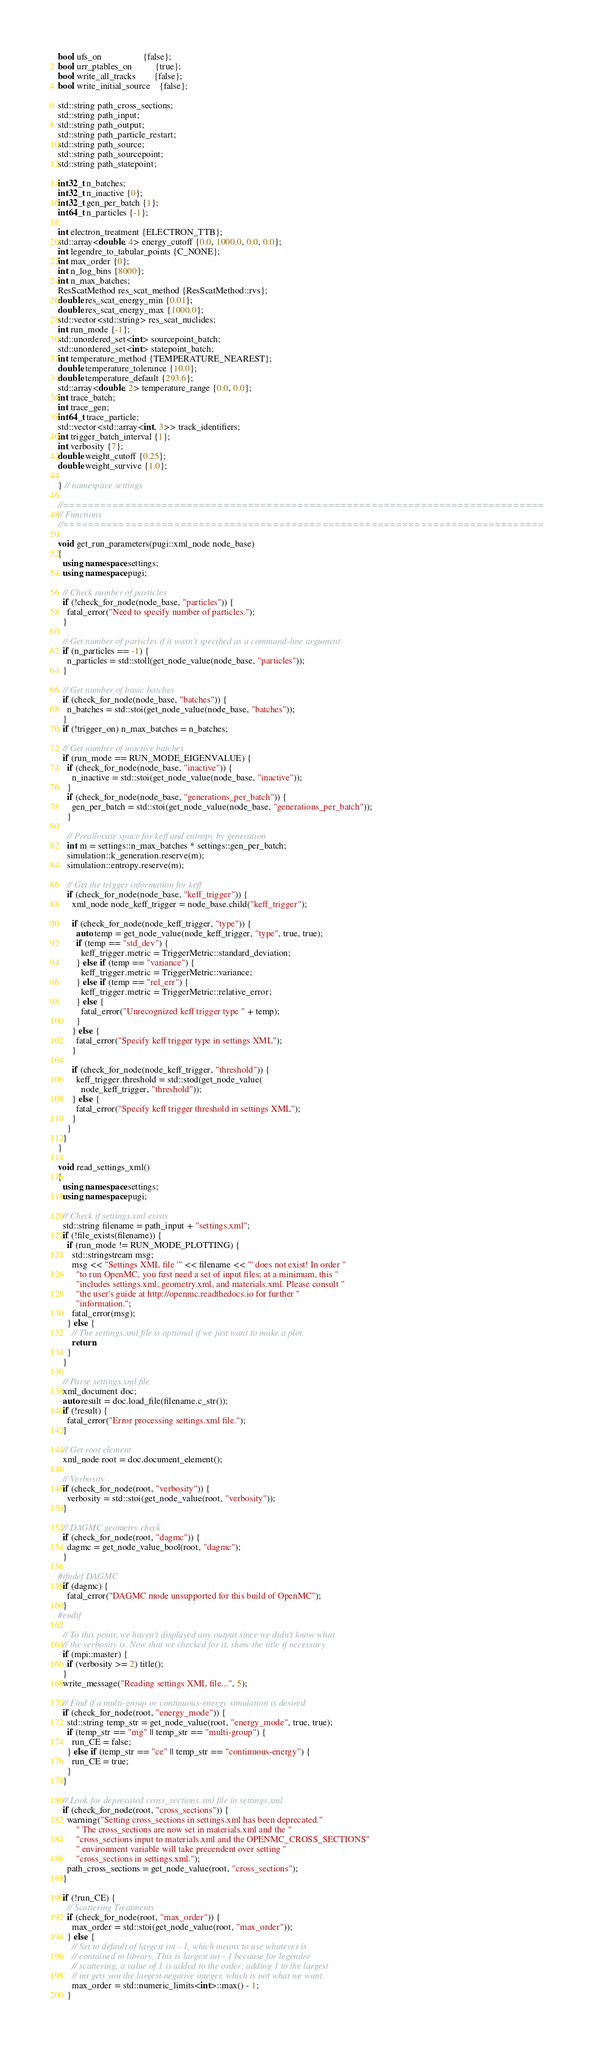<code> <loc_0><loc_0><loc_500><loc_500><_C++_>bool ufs_on                  {false};
bool urr_ptables_on          {true};
bool write_all_tracks        {false};
bool write_initial_source    {false};

std::string path_cross_sections;
std::string path_input;
std::string path_output;
std::string path_particle_restart;
std::string path_source;
std::string path_sourcepoint;
std::string path_statepoint;

int32_t n_batches;
int32_t n_inactive {0};
int32_t gen_per_batch {1};
int64_t n_particles {-1};

int electron_treatment {ELECTRON_TTB};
std::array<double, 4> energy_cutoff {0.0, 1000.0, 0.0, 0.0};
int legendre_to_tabular_points {C_NONE};
int max_order {0};
int n_log_bins {8000};
int n_max_batches;
ResScatMethod res_scat_method {ResScatMethod::rvs};
double res_scat_energy_min {0.01};
double res_scat_energy_max {1000.0};
std::vector<std::string> res_scat_nuclides;
int run_mode {-1};
std::unordered_set<int> sourcepoint_batch;
std::unordered_set<int> statepoint_batch;
int temperature_method {TEMPERATURE_NEAREST};
double temperature_tolerance {10.0};
double temperature_default {293.6};
std::array<double, 2> temperature_range {0.0, 0.0};
int trace_batch;
int trace_gen;
int64_t trace_particle;
std::vector<std::array<int, 3>> track_identifiers;
int trigger_batch_interval {1};
int verbosity {7};
double weight_cutoff {0.25};
double weight_survive {1.0};

} // namespace settings

//==============================================================================
// Functions
//==============================================================================

void get_run_parameters(pugi::xml_node node_base)
{
  using namespace settings;
  using namespace pugi;

  // Check number of particles
  if (!check_for_node(node_base, "particles")) {
    fatal_error("Need to specify number of particles.");
  }

  // Get number of particles if it wasn't specified as a command-line argument
  if (n_particles == -1) {
    n_particles = std::stoll(get_node_value(node_base, "particles"));
  }

  // Get number of basic batches
  if (check_for_node(node_base, "batches")) {
    n_batches = std::stoi(get_node_value(node_base, "batches"));
  }
  if (!trigger_on) n_max_batches = n_batches;

  // Get number of inactive batches
  if (run_mode == RUN_MODE_EIGENVALUE) {
    if (check_for_node(node_base, "inactive")) {
      n_inactive = std::stoi(get_node_value(node_base, "inactive"));
    }
    if (check_for_node(node_base, "generations_per_batch")) {
      gen_per_batch = std::stoi(get_node_value(node_base, "generations_per_batch"));
    }

    // Preallocate space for keff and entropy by generation
    int m = settings::n_max_batches * settings::gen_per_batch;
    simulation::k_generation.reserve(m);
    simulation::entropy.reserve(m);

    // Get the trigger information for keff
    if (check_for_node(node_base, "keff_trigger")) {
      xml_node node_keff_trigger = node_base.child("keff_trigger");

      if (check_for_node(node_keff_trigger, "type")) {
        auto temp = get_node_value(node_keff_trigger, "type", true, true);
        if (temp == "std_dev") {
          keff_trigger.metric = TriggerMetric::standard_deviation;
        } else if (temp == "variance") {
          keff_trigger.metric = TriggerMetric::variance;
        } else if (temp == "rel_err") {
          keff_trigger.metric = TriggerMetric::relative_error;
        } else {
          fatal_error("Unrecognized keff trigger type " + temp);
        }
      } else {
        fatal_error("Specify keff trigger type in settings XML");
      }

      if (check_for_node(node_keff_trigger, "threshold")) {
        keff_trigger.threshold = std::stod(get_node_value(
          node_keff_trigger, "threshold"));
      } else {
        fatal_error("Specify keff trigger threshold in settings XML");
      }
    }
  }
}

void read_settings_xml()
{
  using namespace settings;
  using namespace pugi;

  // Check if settings.xml exists
  std::string filename = path_input + "settings.xml";
  if (!file_exists(filename)) {
    if (run_mode != RUN_MODE_PLOTTING) {
      std::stringstream msg;
      msg << "Settings XML file '" << filename << "' does not exist! In order "
        "to run OpenMC, you first need a set of input files; at a minimum, this "
        "includes settings.xml, geometry.xml, and materials.xml. Please consult "
        "the user's guide at http://openmc.readthedocs.io for further "
        "information.";
      fatal_error(msg);
    } else {
      // The settings.xml file is optional if we just want to make a plot.
      return;
    }
  }

  // Parse settings.xml file
  xml_document doc;
  auto result = doc.load_file(filename.c_str());
  if (!result) {
    fatal_error("Error processing settings.xml file.");
  }

  // Get root element
  xml_node root = doc.document_element();

  // Verbosity
  if (check_for_node(root, "verbosity")) {
    verbosity = std::stoi(get_node_value(root, "verbosity"));
  }

  // DAGMC geometry check
  if (check_for_node(root, "dagmc")) {
    dagmc = get_node_value_bool(root, "dagmc");
  }

#ifndef DAGMC
  if (dagmc) {
    fatal_error("DAGMC mode unsupported for this build of OpenMC");
  }
#endif

  // To this point, we haven't displayed any output since we didn't know what
  // the verbosity is. Now that we checked for it, show the title if necessary
  if (mpi::master) {
    if (verbosity >= 2) title();
  }
  write_message("Reading settings XML file...", 5);

  // Find if a multi-group or continuous-energy simulation is desired
  if (check_for_node(root, "energy_mode")) {
    std::string temp_str = get_node_value(root, "energy_mode", true, true);
    if (temp_str == "mg" || temp_str == "multi-group") {
      run_CE = false;
    } else if (temp_str == "ce" || temp_str == "continuous-energy") {
      run_CE = true;
    }
  }

  // Look for deprecated cross_sections.xml file in settings.xml
  if (check_for_node(root, "cross_sections")) {
    warning("Setting cross_sections in settings.xml has been deprecated."
        " The cross_sections are now set in materials.xml and the "
        "cross_sections input to materials.xml and the OPENMC_CROSS_SECTIONS"
        " environment variable will take precendent over setting "
        "cross_sections in settings.xml.");
    path_cross_sections = get_node_value(root, "cross_sections");
  }

  if (!run_CE) {
    // Scattering Treatments
    if (check_for_node(root, "max_order")) {
      max_order = std::stoi(get_node_value(root, "max_order"));
    } else {
      // Set to default of largest int - 1, which means to use whatever is
      // contained in library. This is largest int - 1 because for legendre
      // scattering, a value of 1 is added to the order; adding 1 to the largest
      // int gets you the largest negative integer, which is not what we want.
      max_order = std::numeric_limits<int>::max() - 1;
    }</code> 